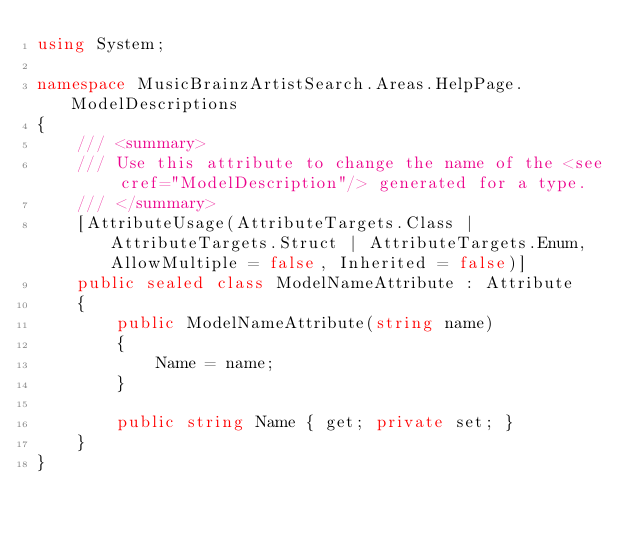Convert code to text. <code><loc_0><loc_0><loc_500><loc_500><_C#_>using System;

namespace MusicBrainzArtistSearch.Areas.HelpPage.ModelDescriptions
{
    /// <summary>
    /// Use this attribute to change the name of the <see cref="ModelDescription"/> generated for a type.
    /// </summary>
    [AttributeUsage(AttributeTargets.Class | AttributeTargets.Struct | AttributeTargets.Enum, AllowMultiple = false, Inherited = false)]
    public sealed class ModelNameAttribute : Attribute
    {
        public ModelNameAttribute(string name)
        {
            Name = name;
        }

        public string Name { get; private set; }
    }
}</code> 